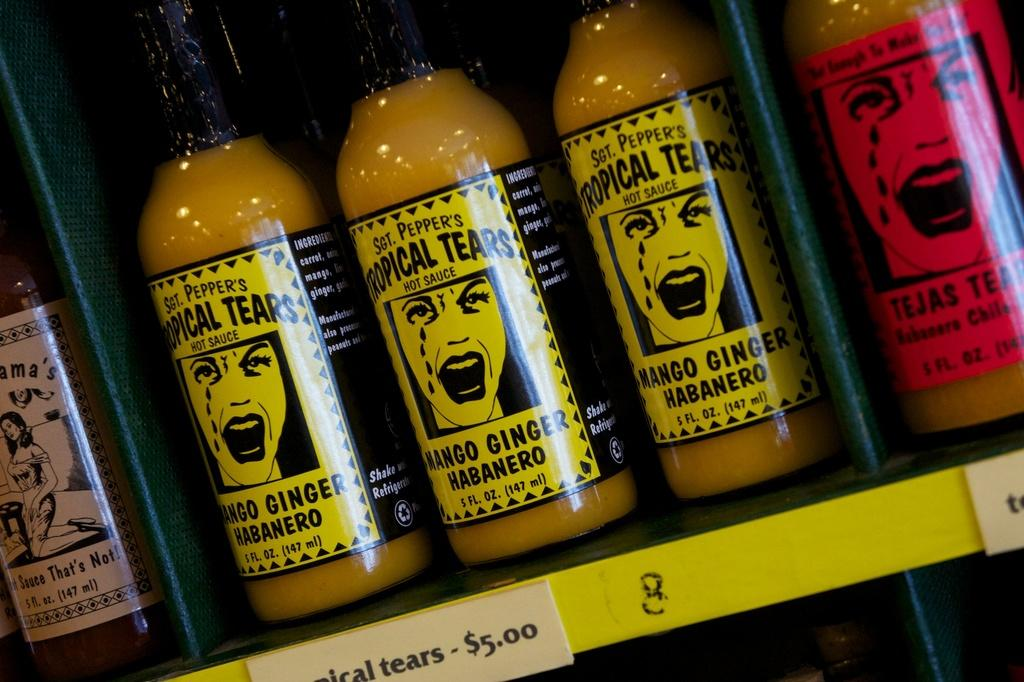<image>
Share a concise interpretation of the image provided. Three bottles of Tropical Tears hot sauce on a shelf 